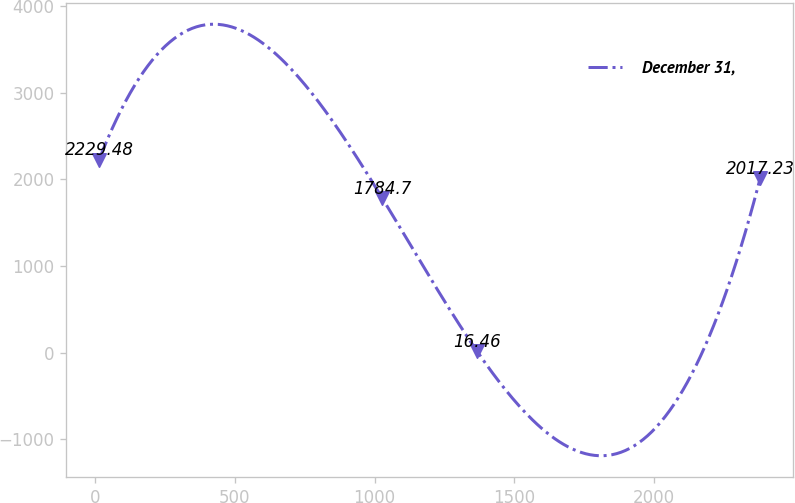Convert chart. <chart><loc_0><loc_0><loc_500><loc_500><line_chart><ecel><fcel>December 31,<nl><fcel>14.27<fcel>2229.48<nl><fcel>1027.21<fcel>1784.7<nl><fcel>1366.41<fcel>16.46<nl><fcel>2380.5<fcel>2017.23<nl></chart> 